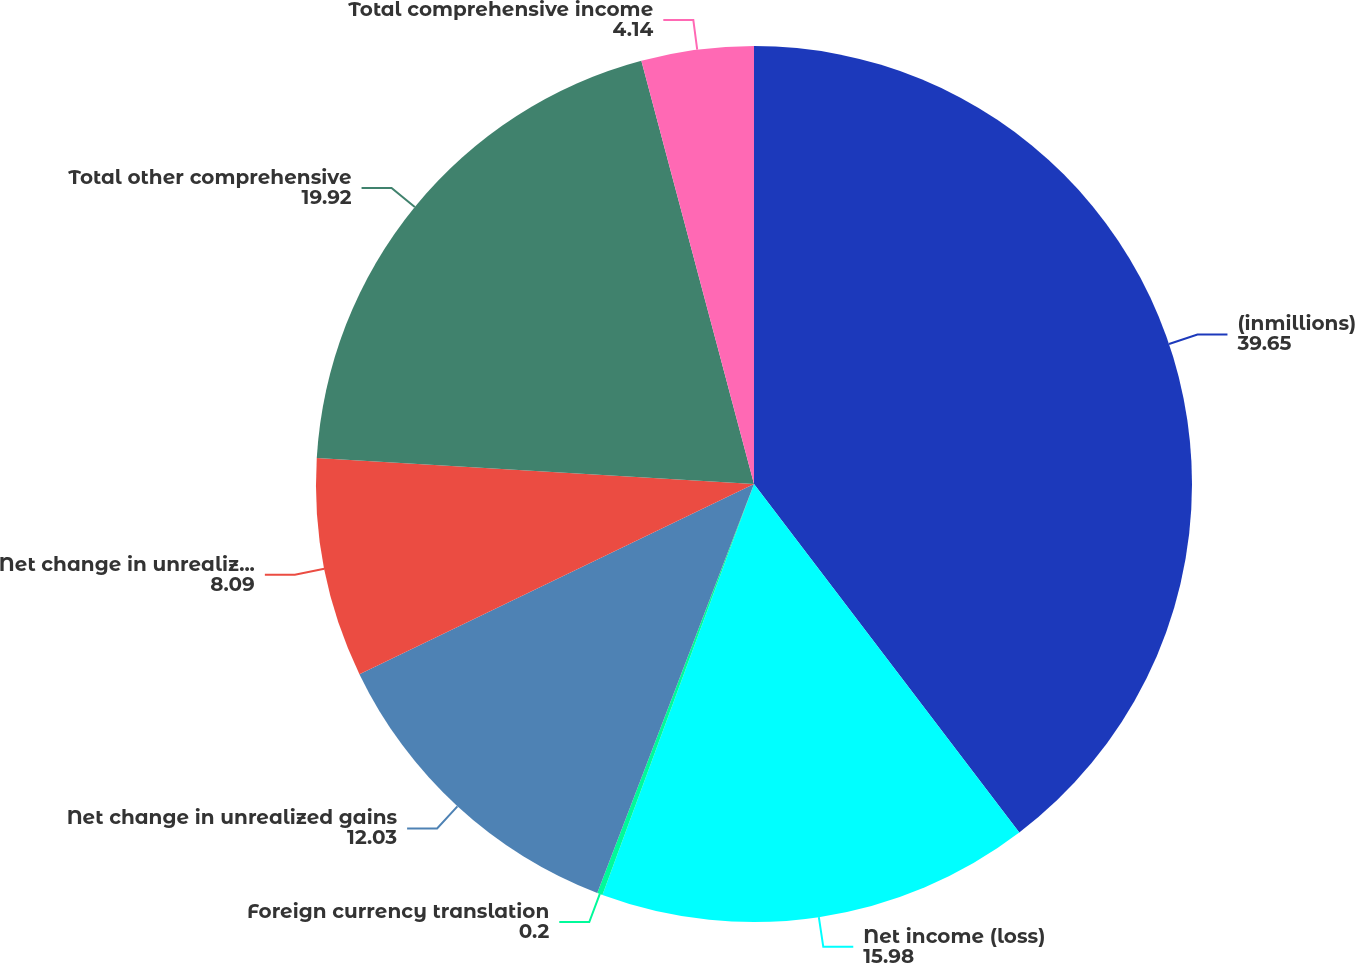Convert chart. <chart><loc_0><loc_0><loc_500><loc_500><pie_chart><fcel>(inmillions)<fcel>Net income (loss)<fcel>Foreign currency translation<fcel>Net change in unrealized gains<fcel>Net change in unrealized costs<fcel>Total other comprehensive<fcel>Total comprehensive income<nl><fcel>39.65%<fcel>15.98%<fcel>0.2%<fcel>12.03%<fcel>8.09%<fcel>19.92%<fcel>4.14%<nl></chart> 